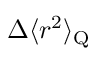Convert formula to latex. <formula><loc_0><loc_0><loc_500><loc_500>\Delta \langle r ^ { 2 } \rangle _ { Q }</formula> 